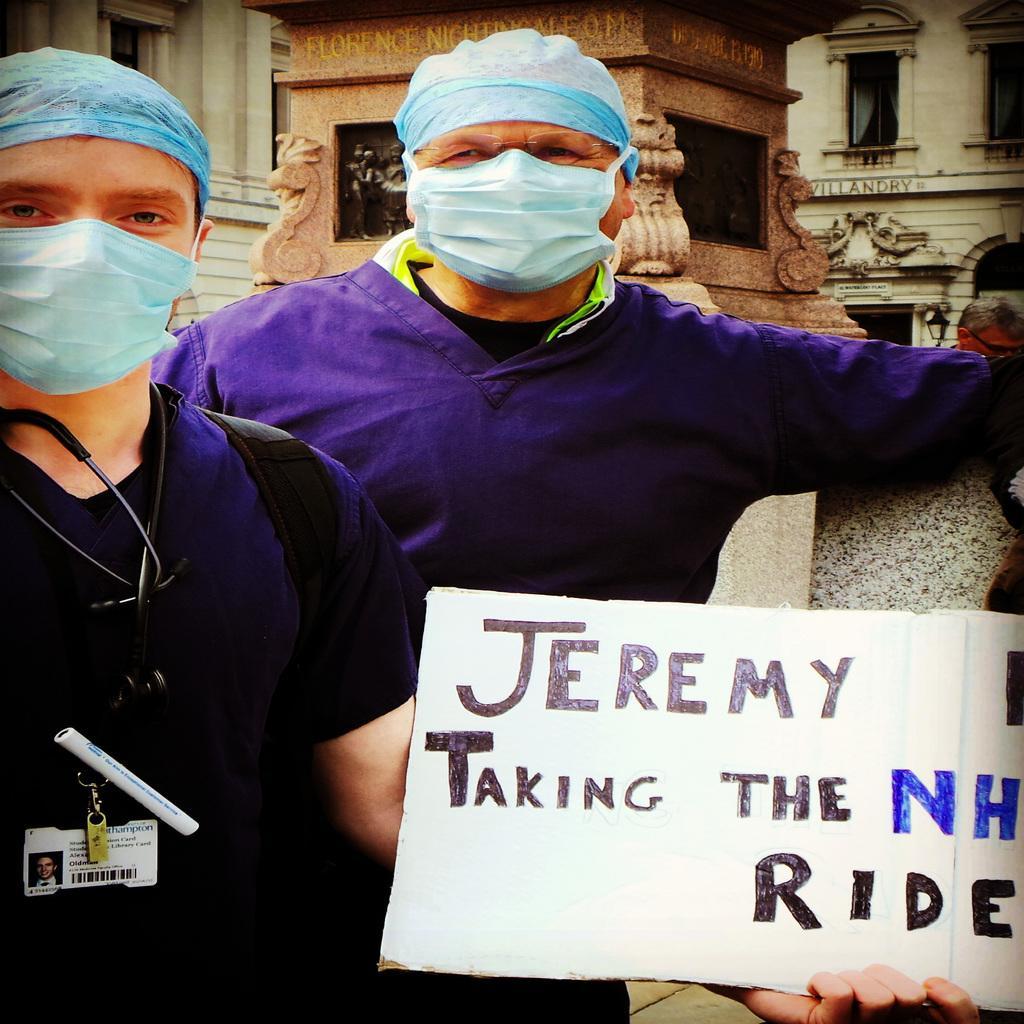Could you give a brief overview of what you see in this image? There are two men standing and holding a poster as we can see in the middle of this image. We can see the buildings in the background. 